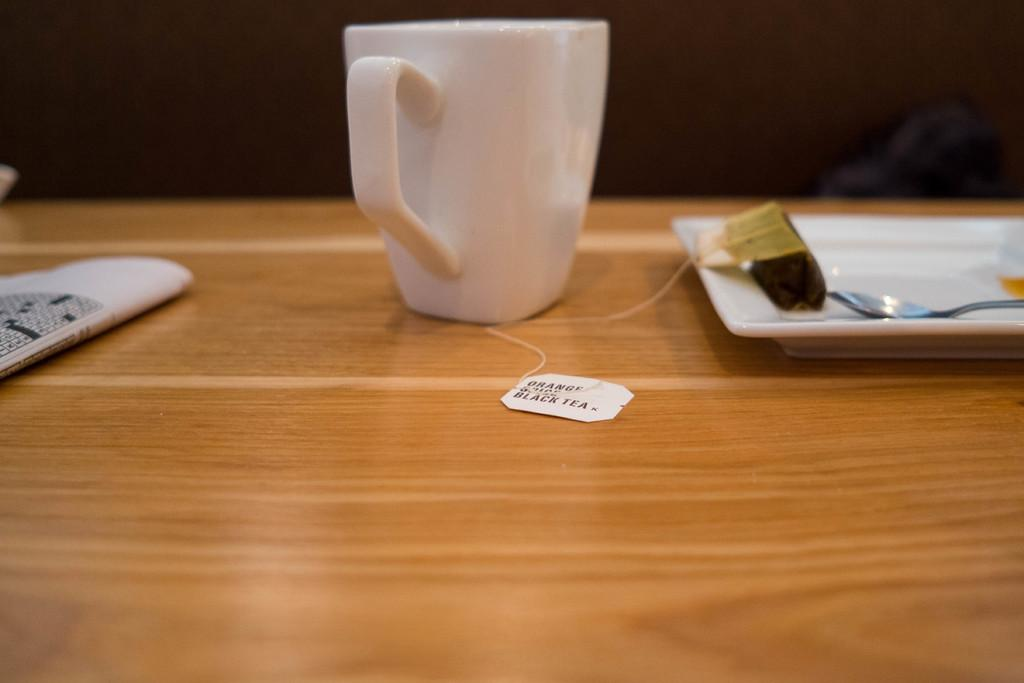What piece of furniture is present in the image? There is a table in the image. What is placed on the table? There is a cup, a plate, and a spoon on the table. What song is being played in the background of the image? There is no indication of any music or song being played in the image. 